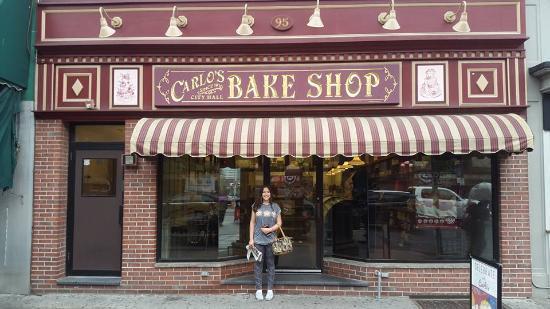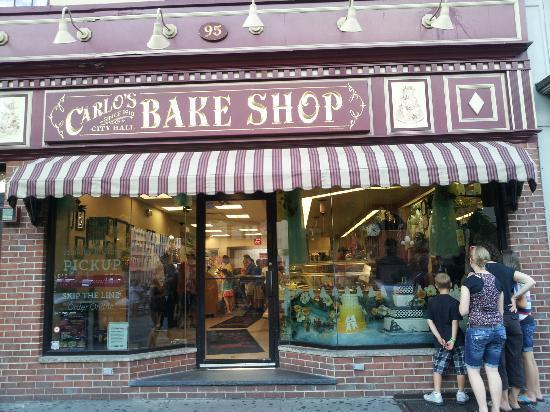The first image is the image on the left, the second image is the image on the right. Given the left and right images, does the statement "There is at least one person standing outside the store in the image on the right." hold true? Answer yes or no. Yes. 